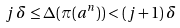<formula> <loc_0><loc_0><loc_500><loc_500>j \, \delta \leq \Delta ( \pi ( a ^ { n } ) ) < ( j + 1 ) \, \delta</formula> 